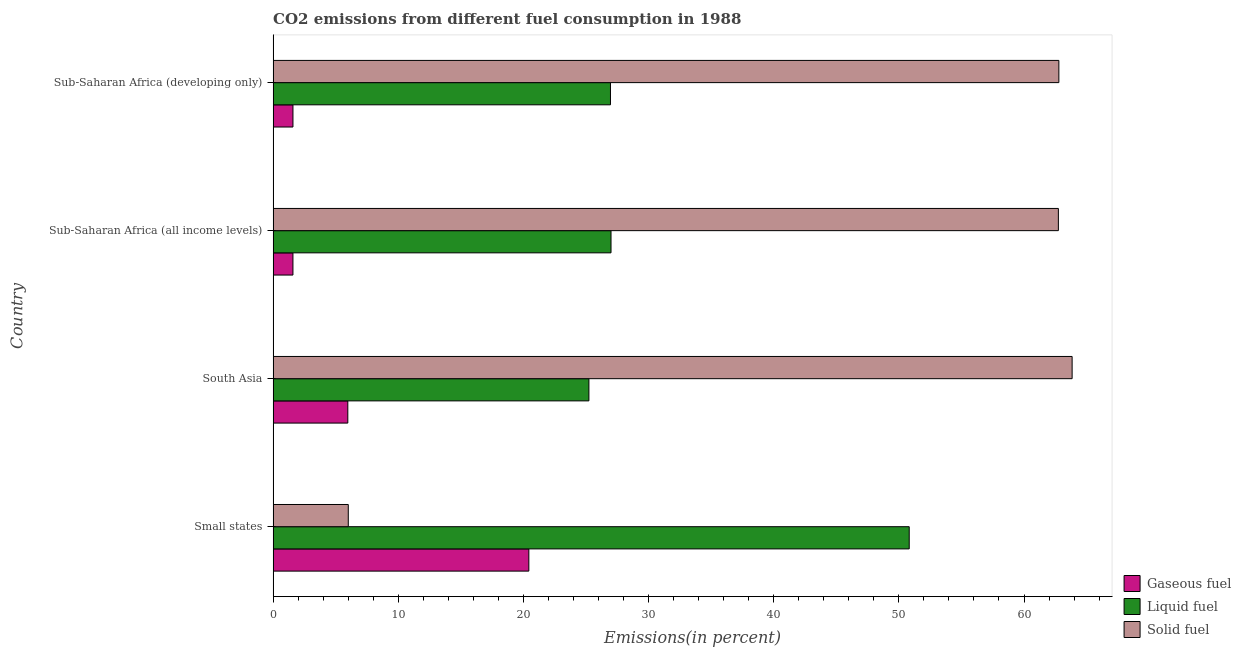How many different coloured bars are there?
Your response must be concise. 3. Are the number of bars on each tick of the Y-axis equal?
Your answer should be very brief. Yes. How many bars are there on the 3rd tick from the top?
Your answer should be very brief. 3. What is the label of the 4th group of bars from the top?
Provide a short and direct response. Small states. In how many cases, is the number of bars for a given country not equal to the number of legend labels?
Provide a succinct answer. 0. What is the percentage of gaseous fuel emission in South Asia?
Your answer should be very brief. 5.97. Across all countries, what is the maximum percentage of solid fuel emission?
Ensure brevity in your answer.  63.84. Across all countries, what is the minimum percentage of liquid fuel emission?
Your answer should be compact. 25.23. In which country was the percentage of gaseous fuel emission maximum?
Offer a terse response. Small states. In which country was the percentage of gaseous fuel emission minimum?
Offer a terse response. Sub-Saharan Africa (all income levels). What is the total percentage of gaseous fuel emission in the graph?
Give a very brief answer. 29.57. What is the difference between the percentage of gaseous fuel emission in Sub-Saharan Africa (all income levels) and that in Sub-Saharan Africa (developing only)?
Your answer should be compact. -0. What is the difference between the percentage of liquid fuel emission in Small states and the percentage of solid fuel emission in Sub-Saharan Africa (developing only)?
Ensure brevity in your answer.  -11.96. What is the average percentage of liquid fuel emission per country?
Provide a short and direct response. 32.5. What is the difference between the percentage of gaseous fuel emission and percentage of solid fuel emission in Small states?
Your response must be concise. 14.43. In how many countries, is the percentage of solid fuel emission greater than 44 %?
Offer a very short reply. 3. What is the ratio of the percentage of liquid fuel emission in South Asia to that in Sub-Saharan Africa (developing only)?
Offer a very short reply. 0.94. Is the percentage of gaseous fuel emission in Small states less than that in Sub-Saharan Africa (all income levels)?
Your answer should be compact. No. What is the difference between the highest and the second highest percentage of solid fuel emission?
Keep it short and to the point. 1.06. What is the difference between the highest and the lowest percentage of solid fuel emission?
Ensure brevity in your answer.  57.84. In how many countries, is the percentage of solid fuel emission greater than the average percentage of solid fuel emission taken over all countries?
Make the answer very short. 3. Is the sum of the percentage of gaseous fuel emission in Small states and South Asia greater than the maximum percentage of solid fuel emission across all countries?
Ensure brevity in your answer.  No. What does the 2nd bar from the top in Sub-Saharan Africa (developing only) represents?
Provide a short and direct response. Liquid fuel. What does the 2nd bar from the bottom in Sub-Saharan Africa (all income levels) represents?
Offer a terse response. Liquid fuel. Are all the bars in the graph horizontal?
Offer a terse response. Yes. What is the difference between two consecutive major ticks on the X-axis?
Provide a succinct answer. 10. Are the values on the major ticks of X-axis written in scientific E-notation?
Ensure brevity in your answer.  No. Does the graph contain any zero values?
Offer a terse response. No. Where does the legend appear in the graph?
Provide a short and direct response. Bottom right. How many legend labels are there?
Make the answer very short. 3. How are the legend labels stacked?
Your answer should be very brief. Vertical. What is the title of the graph?
Make the answer very short. CO2 emissions from different fuel consumption in 1988. What is the label or title of the X-axis?
Your answer should be very brief. Emissions(in percent). What is the Emissions(in percent) of Gaseous fuel in Small states?
Your answer should be compact. 20.43. What is the Emissions(in percent) in Liquid fuel in Small states?
Provide a succinct answer. 50.83. What is the Emissions(in percent) in Solid fuel in Small states?
Your answer should be very brief. 6.01. What is the Emissions(in percent) in Gaseous fuel in South Asia?
Provide a short and direct response. 5.97. What is the Emissions(in percent) of Liquid fuel in South Asia?
Ensure brevity in your answer.  25.23. What is the Emissions(in percent) of Solid fuel in South Asia?
Give a very brief answer. 63.84. What is the Emissions(in percent) of Gaseous fuel in Sub-Saharan Africa (all income levels)?
Provide a succinct answer. 1.58. What is the Emissions(in percent) in Liquid fuel in Sub-Saharan Africa (all income levels)?
Your answer should be very brief. 27. What is the Emissions(in percent) in Solid fuel in Sub-Saharan Africa (all income levels)?
Give a very brief answer. 62.75. What is the Emissions(in percent) in Gaseous fuel in Sub-Saharan Africa (developing only)?
Make the answer very short. 1.58. What is the Emissions(in percent) of Liquid fuel in Sub-Saharan Africa (developing only)?
Your answer should be very brief. 26.96. What is the Emissions(in percent) of Solid fuel in Sub-Saharan Africa (developing only)?
Your response must be concise. 62.78. Across all countries, what is the maximum Emissions(in percent) in Gaseous fuel?
Offer a very short reply. 20.43. Across all countries, what is the maximum Emissions(in percent) of Liquid fuel?
Your answer should be very brief. 50.83. Across all countries, what is the maximum Emissions(in percent) in Solid fuel?
Make the answer very short. 63.84. Across all countries, what is the minimum Emissions(in percent) of Gaseous fuel?
Offer a terse response. 1.58. Across all countries, what is the minimum Emissions(in percent) in Liquid fuel?
Keep it short and to the point. 25.23. Across all countries, what is the minimum Emissions(in percent) of Solid fuel?
Offer a very short reply. 6.01. What is the total Emissions(in percent) in Gaseous fuel in the graph?
Ensure brevity in your answer.  29.57. What is the total Emissions(in percent) in Liquid fuel in the graph?
Ensure brevity in your answer.  130.02. What is the total Emissions(in percent) in Solid fuel in the graph?
Ensure brevity in your answer.  195.38. What is the difference between the Emissions(in percent) in Gaseous fuel in Small states and that in South Asia?
Offer a terse response. 14.47. What is the difference between the Emissions(in percent) in Liquid fuel in Small states and that in South Asia?
Your answer should be compact. 25.59. What is the difference between the Emissions(in percent) in Solid fuel in Small states and that in South Asia?
Offer a terse response. -57.84. What is the difference between the Emissions(in percent) of Gaseous fuel in Small states and that in Sub-Saharan Africa (all income levels)?
Give a very brief answer. 18.85. What is the difference between the Emissions(in percent) in Liquid fuel in Small states and that in Sub-Saharan Africa (all income levels)?
Ensure brevity in your answer.  23.83. What is the difference between the Emissions(in percent) in Solid fuel in Small states and that in Sub-Saharan Africa (all income levels)?
Give a very brief answer. -56.74. What is the difference between the Emissions(in percent) in Gaseous fuel in Small states and that in Sub-Saharan Africa (developing only)?
Your answer should be very brief. 18.85. What is the difference between the Emissions(in percent) of Liquid fuel in Small states and that in Sub-Saharan Africa (developing only)?
Your answer should be compact. 23.87. What is the difference between the Emissions(in percent) of Solid fuel in Small states and that in Sub-Saharan Africa (developing only)?
Give a very brief answer. -56.78. What is the difference between the Emissions(in percent) of Gaseous fuel in South Asia and that in Sub-Saharan Africa (all income levels)?
Your response must be concise. 4.39. What is the difference between the Emissions(in percent) in Liquid fuel in South Asia and that in Sub-Saharan Africa (all income levels)?
Offer a very short reply. -1.77. What is the difference between the Emissions(in percent) in Solid fuel in South Asia and that in Sub-Saharan Africa (all income levels)?
Give a very brief answer. 1.1. What is the difference between the Emissions(in percent) of Gaseous fuel in South Asia and that in Sub-Saharan Africa (developing only)?
Your answer should be very brief. 4.38. What is the difference between the Emissions(in percent) in Liquid fuel in South Asia and that in Sub-Saharan Africa (developing only)?
Make the answer very short. -1.72. What is the difference between the Emissions(in percent) in Solid fuel in South Asia and that in Sub-Saharan Africa (developing only)?
Give a very brief answer. 1.06. What is the difference between the Emissions(in percent) in Gaseous fuel in Sub-Saharan Africa (all income levels) and that in Sub-Saharan Africa (developing only)?
Provide a short and direct response. -0. What is the difference between the Emissions(in percent) of Liquid fuel in Sub-Saharan Africa (all income levels) and that in Sub-Saharan Africa (developing only)?
Give a very brief answer. 0.04. What is the difference between the Emissions(in percent) of Solid fuel in Sub-Saharan Africa (all income levels) and that in Sub-Saharan Africa (developing only)?
Offer a very short reply. -0.04. What is the difference between the Emissions(in percent) in Gaseous fuel in Small states and the Emissions(in percent) in Liquid fuel in South Asia?
Provide a succinct answer. -4.8. What is the difference between the Emissions(in percent) in Gaseous fuel in Small states and the Emissions(in percent) in Solid fuel in South Asia?
Your answer should be very brief. -43.41. What is the difference between the Emissions(in percent) in Liquid fuel in Small states and the Emissions(in percent) in Solid fuel in South Asia?
Your response must be concise. -13.02. What is the difference between the Emissions(in percent) of Gaseous fuel in Small states and the Emissions(in percent) of Liquid fuel in Sub-Saharan Africa (all income levels)?
Your answer should be compact. -6.57. What is the difference between the Emissions(in percent) in Gaseous fuel in Small states and the Emissions(in percent) in Solid fuel in Sub-Saharan Africa (all income levels)?
Provide a succinct answer. -42.31. What is the difference between the Emissions(in percent) of Liquid fuel in Small states and the Emissions(in percent) of Solid fuel in Sub-Saharan Africa (all income levels)?
Provide a short and direct response. -11.92. What is the difference between the Emissions(in percent) of Gaseous fuel in Small states and the Emissions(in percent) of Liquid fuel in Sub-Saharan Africa (developing only)?
Your answer should be compact. -6.52. What is the difference between the Emissions(in percent) of Gaseous fuel in Small states and the Emissions(in percent) of Solid fuel in Sub-Saharan Africa (developing only)?
Ensure brevity in your answer.  -42.35. What is the difference between the Emissions(in percent) of Liquid fuel in Small states and the Emissions(in percent) of Solid fuel in Sub-Saharan Africa (developing only)?
Offer a terse response. -11.96. What is the difference between the Emissions(in percent) in Gaseous fuel in South Asia and the Emissions(in percent) in Liquid fuel in Sub-Saharan Africa (all income levels)?
Your answer should be very brief. -21.03. What is the difference between the Emissions(in percent) in Gaseous fuel in South Asia and the Emissions(in percent) in Solid fuel in Sub-Saharan Africa (all income levels)?
Give a very brief answer. -56.78. What is the difference between the Emissions(in percent) in Liquid fuel in South Asia and the Emissions(in percent) in Solid fuel in Sub-Saharan Africa (all income levels)?
Make the answer very short. -37.51. What is the difference between the Emissions(in percent) in Gaseous fuel in South Asia and the Emissions(in percent) in Liquid fuel in Sub-Saharan Africa (developing only)?
Make the answer very short. -20.99. What is the difference between the Emissions(in percent) in Gaseous fuel in South Asia and the Emissions(in percent) in Solid fuel in Sub-Saharan Africa (developing only)?
Offer a terse response. -56.82. What is the difference between the Emissions(in percent) in Liquid fuel in South Asia and the Emissions(in percent) in Solid fuel in Sub-Saharan Africa (developing only)?
Your response must be concise. -37.55. What is the difference between the Emissions(in percent) in Gaseous fuel in Sub-Saharan Africa (all income levels) and the Emissions(in percent) in Liquid fuel in Sub-Saharan Africa (developing only)?
Make the answer very short. -25.37. What is the difference between the Emissions(in percent) in Gaseous fuel in Sub-Saharan Africa (all income levels) and the Emissions(in percent) in Solid fuel in Sub-Saharan Africa (developing only)?
Offer a very short reply. -61.2. What is the difference between the Emissions(in percent) in Liquid fuel in Sub-Saharan Africa (all income levels) and the Emissions(in percent) in Solid fuel in Sub-Saharan Africa (developing only)?
Provide a succinct answer. -35.78. What is the average Emissions(in percent) in Gaseous fuel per country?
Make the answer very short. 7.39. What is the average Emissions(in percent) of Liquid fuel per country?
Keep it short and to the point. 32.5. What is the average Emissions(in percent) of Solid fuel per country?
Keep it short and to the point. 48.85. What is the difference between the Emissions(in percent) in Gaseous fuel and Emissions(in percent) in Liquid fuel in Small states?
Provide a short and direct response. -30.39. What is the difference between the Emissions(in percent) of Gaseous fuel and Emissions(in percent) of Solid fuel in Small states?
Make the answer very short. 14.43. What is the difference between the Emissions(in percent) in Liquid fuel and Emissions(in percent) in Solid fuel in Small states?
Give a very brief answer. 44.82. What is the difference between the Emissions(in percent) in Gaseous fuel and Emissions(in percent) in Liquid fuel in South Asia?
Make the answer very short. -19.26. What is the difference between the Emissions(in percent) of Gaseous fuel and Emissions(in percent) of Solid fuel in South Asia?
Make the answer very short. -57.88. What is the difference between the Emissions(in percent) in Liquid fuel and Emissions(in percent) in Solid fuel in South Asia?
Provide a succinct answer. -38.61. What is the difference between the Emissions(in percent) of Gaseous fuel and Emissions(in percent) of Liquid fuel in Sub-Saharan Africa (all income levels)?
Give a very brief answer. -25.42. What is the difference between the Emissions(in percent) of Gaseous fuel and Emissions(in percent) of Solid fuel in Sub-Saharan Africa (all income levels)?
Provide a short and direct response. -61.16. What is the difference between the Emissions(in percent) in Liquid fuel and Emissions(in percent) in Solid fuel in Sub-Saharan Africa (all income levels)?
Keep it short and to the point. -35.75. What is the difference between the Emissions(in percent) in Gaseous fuel and Emissions(in percent) in Liquid fuel in Sub-Saharan Africa (developing only)?
Provide a succinct answer. -25.37. What is the difference between the Emissions(in percent) of Gaseous fuel and Emissions(in percent) of Solid fuel in Sub-Saharan Africa (developing only)?
Keep it short and to the point. -61.2. What is the difference between the Emissions(in percent) in Liquid fuel and Emissions(in percent) in Solid fuel in Sub-Saharan Africa (developing only)?
Your answer should be very brief. -35.83. What is the ratio of the Emissions(in percent) in Gaseous fuel in Small states to that in South Asia?
Provide a short and direct response. 3.42. What is the ratio of the Emissions(in percent) of Liquid fuel in Small states to that in South Asia?
Provide a succinct answer. 2.01. What is the ratio of the Emissions(in percent) in Solid fuel in Small states to that in South Asia?
Provide a succinct answer. 0.09. What is the ratio of the Emissions(in percent) of Gaseous fuel in Small states to that in Sub-Saharan Africa (all income levels)?
Keep it short and to the point. 12.9. What is the ratio of the Emissions(in percent) in Liquid fuel in Small states to that in Sub-Saharan Africa (all income levels)?
Keep it short and to the point. 1.88. What is the ratio of the Emissions(in percent) in Solid fuel in Small states to that in Sub-Saharan Africa (all income levels)?
Ensure brevity in your answer.  0.1. What is the ratio of the Emissions(in percent) in Gaseous fuel in Small states to that in Sub-Saharan Africa (developing only)?
Ensure brevity in your answer.  12.9. What is the ratio of the Emissions(in percent) of Liquid fuel in Small states to that in Sub-Saharan Africa (developing only)?
Give a very brief answer. 1.89. What is the ratio of the Emissions(in percent) of Solid fuel in Small states to that in Sub-Saharan Africa (developing only)?
Your answer should be compact. 0.1. What is the ratio of the Emissions(in percent) of Gaseous fuel in South Asia to that in Sub-Saharan Africa (all income levels)?
Make the answer very short. 3.77. What is the ratio of the Emissions(in percent) of Liquid fuel in South Asia to that in Sub-Saharan Africa (all income levels)?
Your answer should be compact. 0.93. What is the ratio of the Emissions(in percent) of Solid fuel in South Asia to that in Sub-Saharan Africa (all income levels)?
Your answer should be very brief. 1.02. What is the ratio of the Emissions(in percent) in Gaseous fuel in South Asia to that in Sub-Saharan Africa (developing only)?
Make the answer very short. 3.77. What is the ratio of the Emissions(in percent) of Liquid fuel in South Asia to that in Sub-Saharan Africa (developing only)?
Offer a terse response. 0.94. What is the ratio of the Emissions(in percent) of Solid fuel in South Asia to that in Sub-Saharan Africa (developing only)?
Your response must be concise. 1.02. What is the ratio of the Emissions(in percent) of Gaseous fuel in Sub-Saharan Africa (all income levels) to that in Sub-Saharan Africa (developing only)?
Offer a very short reply. 1. What is the difference between the highest and the second highest Emissions(in percent) in Gaseous fuel?
Keep it short and to the point. 14.47. What is the difference between the highest and the second highest Emissions(in percent) of Liquid fuel?
Make the answer very short. 23.83. What is the difference between the highest and the second highest Emissions(in percent) in Solid fuel?
Keep it short and to the point. 1.06. What is the difference between the highest and the lowest Emissions(in percent) of Gaseous fuel?
Make the answer very short. 18.85. What is the difference between the highest and the lowest Emissions(in percent) of Liquid fuel?
Your answer should be very brief. 25.59. What is the difference between the highest and the lowest Emissions(in percent) of Solid fuel?
Give a very brief answer. 57.84. 